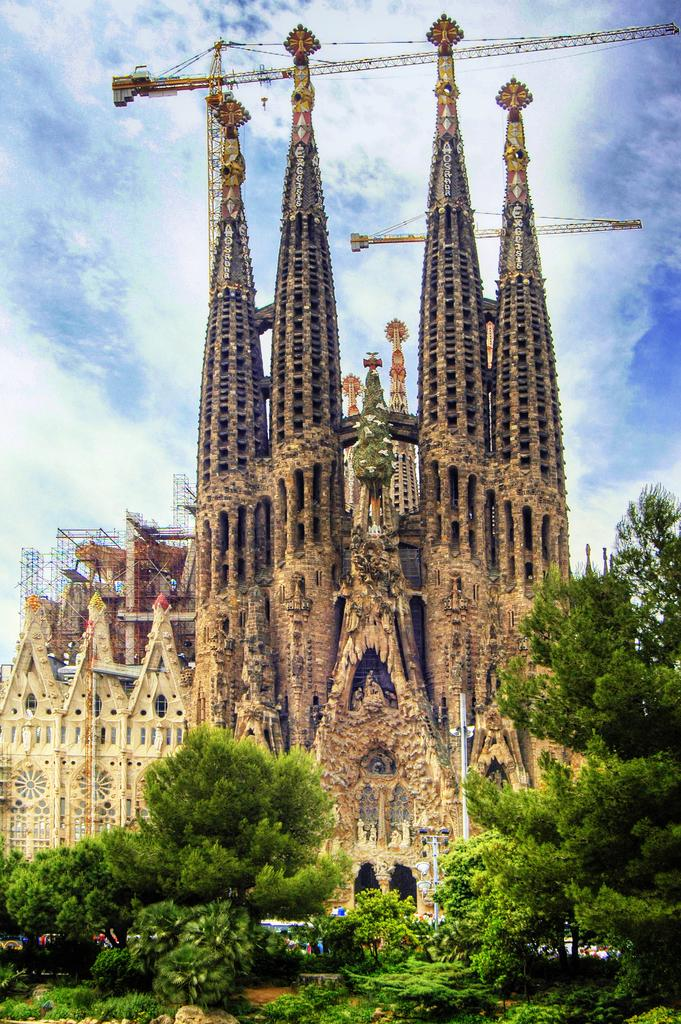What type of structures can be seen in the image? There are buildings in the image. What equipment is present in the image? There are cranes in the image. What other objects can be seen in the image? There are poles in the image. What type of natural environment is visible in the image? There is ground with plants and trees in the image. What is visible in the sky in the image? The sky is visible in the image, and there are clouds in the sky. Can you see a crowd of rabbits on a boat in the image? There is no crowd of rabbits on a boat present in the image. 